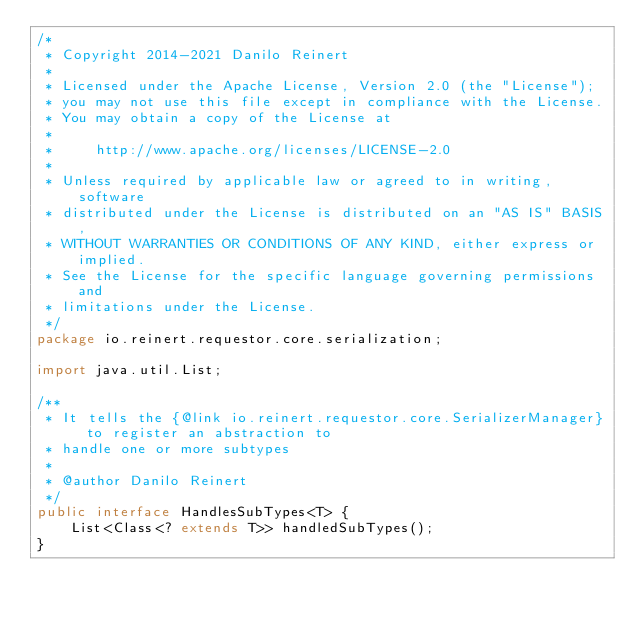Convert code to text. <code><loc_0><loc_0><loc_500><loc_500><_Java_>/*
 * Copyright 2014-2021 Danilo Reinert
 *
 * Licensed under the Apache License, Version 2.0 (the "License");
 * you may not use this file except in compliance with the License.
 * You may obtain a copy of the License at
 *
 *     http://www.apache.org/licenses/LICENSE-2.0
 *
 * Unless required by applicable law or agreed to in writing, software
 * distributed under the License is distributed on an "AS IS" BASIS,
 * WITHOUT WARRANTIES OR CONDITIONS OF ANY KIND, either express or implied.
 * See the License for the specific language governing permissions and
 * limitations under the License.
 */
package io.reinert.requestor.core.serialization;

import java.util.List;

/**
 * It tells the {@link io.reinert.requestor.core.SerializerManager} to register an abstraction to
 * handle one or more subtypes
 *
 * @author Danilo Reinert
 */
public interface HandlesSubTypes<T> {
    List<Class<? extends T>> handledSubTypes();
}
</code> 